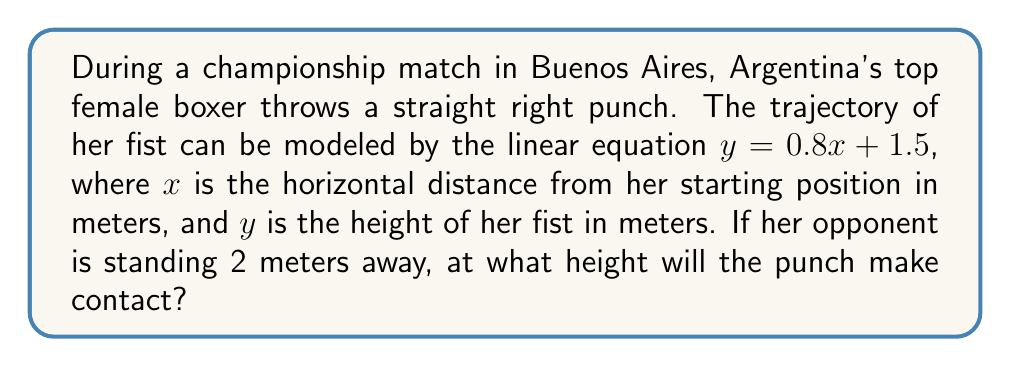Provide a solution to this math problem. To solve this problem, we'll follow these steps:

1. Identify the given information:
   - The linear equation modeling the punch trajectory: $y = 0.8x + 1.5$
   - The opponent's distance: $x = 2$ meters

2. Substitute the $x$-value into the equation:
   $y = 0.8(2) + 1.5$

3. Solve for $y$:
   $y = 1.6 + 1.5$
   $y = 3.1$

Therefore, the punch will make contact at a height of 3.1 meters.

[asy]
unitsize(1cm);
draw((0,0)--(4,0), arrow=Arrow(TeXHead));
draw((0,0)--(0,4), arrow=Arrow(TeXHead));
draw((0,1.5)--(2.5,3.5), blue);
dot((2,3.1), red);
label("$x$", (4,0), E);
label("$y$", (0,4), N);
label("$y = 0.8x + 1.5$", (2.5,3.5), NE, blue);
label("Contact point", (2,3.1), SE, red);
[/asy]
Answer: 3.1 meters 